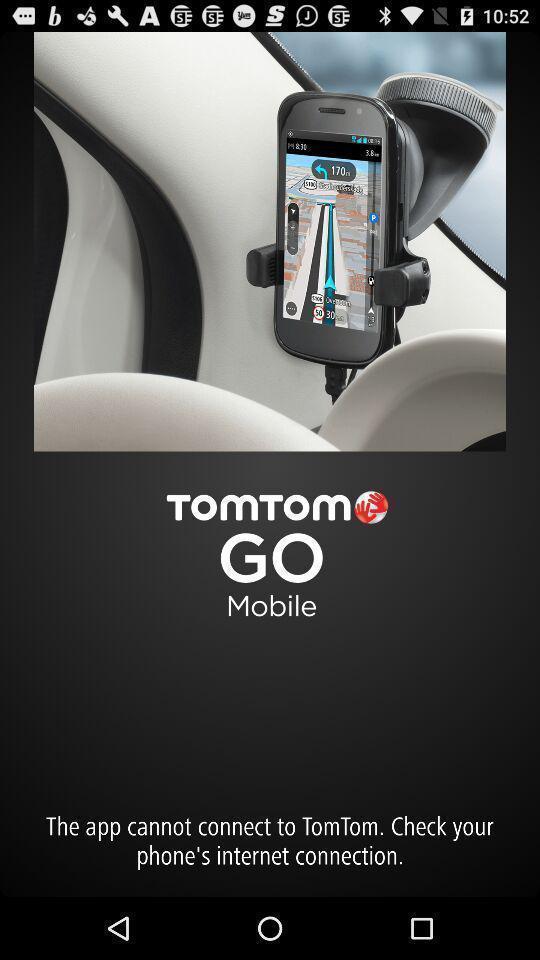What details can you identify in this image? Screen displaying information of a navigation application. 